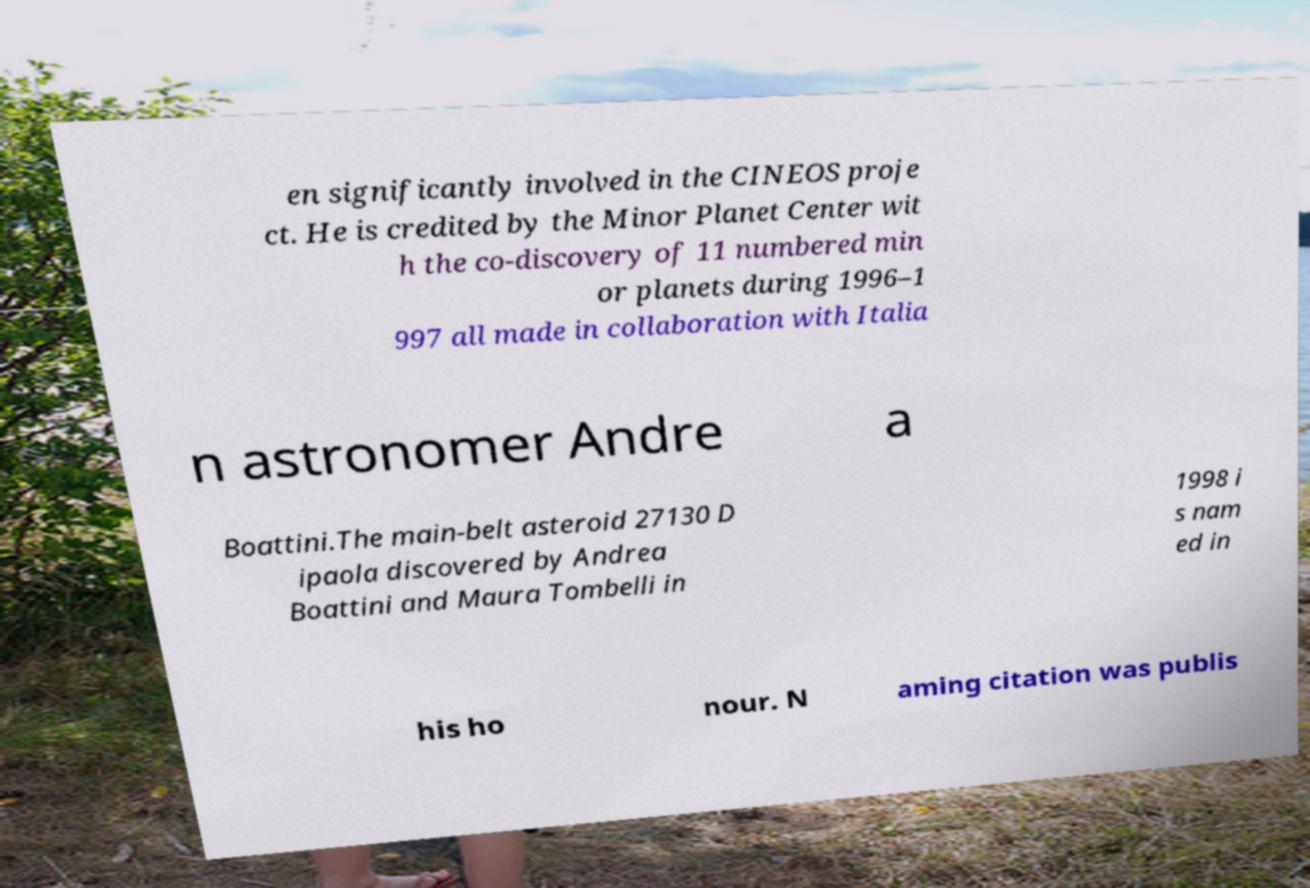What messages or text are displayed in this image? I need them in a readable, typed format. en significantly involved in the CINEOS proje ct. He is credited by the Minor Planet Center wit h the co-discovery of 11 numbered min or planets during 1996–1 997 all made in collaboration with Italia n astronomer Andre a Boattini.The main-belt asteroid 27130 D ipaola discovered by Andrea Boattini and Maura Tombelli in 1998 i s nam ed in his ho nour. N aming citation was publis 